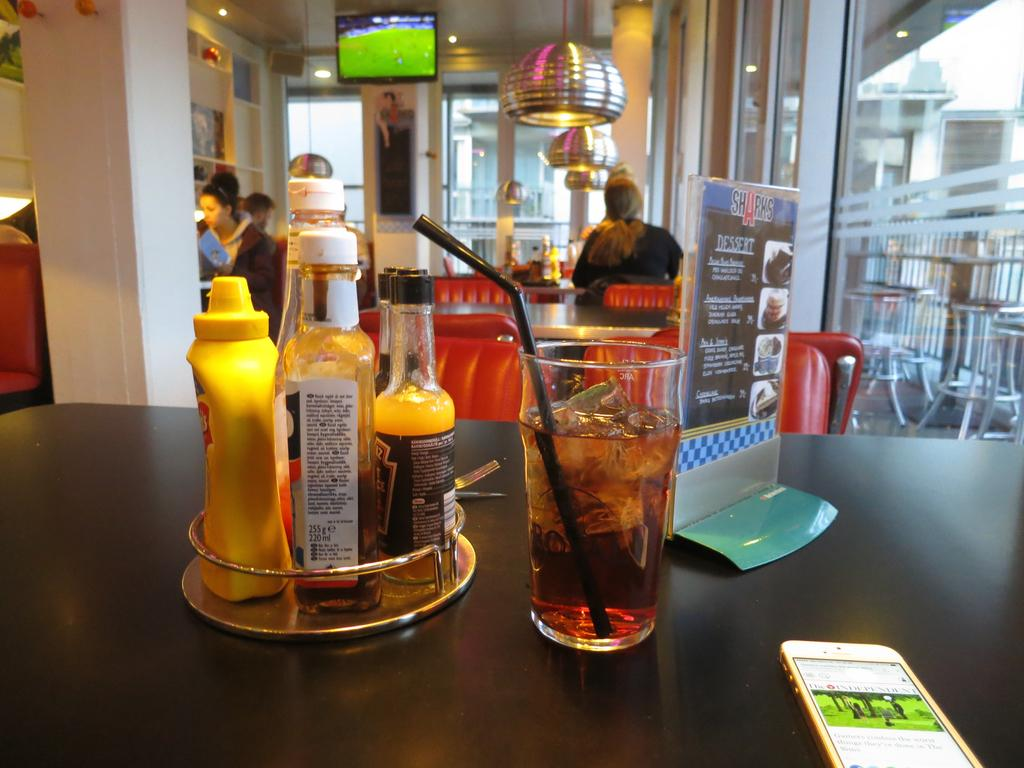Where was the image taken? The image was taken in a restaurant. What can be seen on the table in the image? There is food and eatables on a table in the image. What is present on the table that might help with ordering food? There is a menu card on the table. What type of fear can be seen on the faces of the spiders in the image? There are no spiders present in the image, so it is not possible to determine if they are experiencing any fear. 